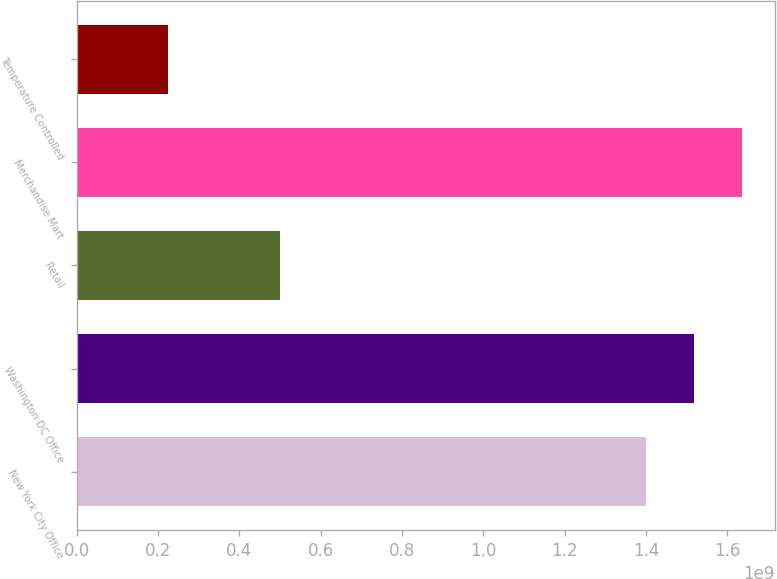Convert chart. <chart><loc_0><loc_0><loc_500><loc_500><bar_chart><fcel>New York City Office<fcel>Washington DC Office<fcel>Retail<fcel>Merchandise Mart<fcel>Temperature Controlled<nl><fcel>1.4e+09<fcel>1.5175e+09<fcel>5e+08<fcel>1.635e+09<fcel>2.25e+08<nl></chart> 